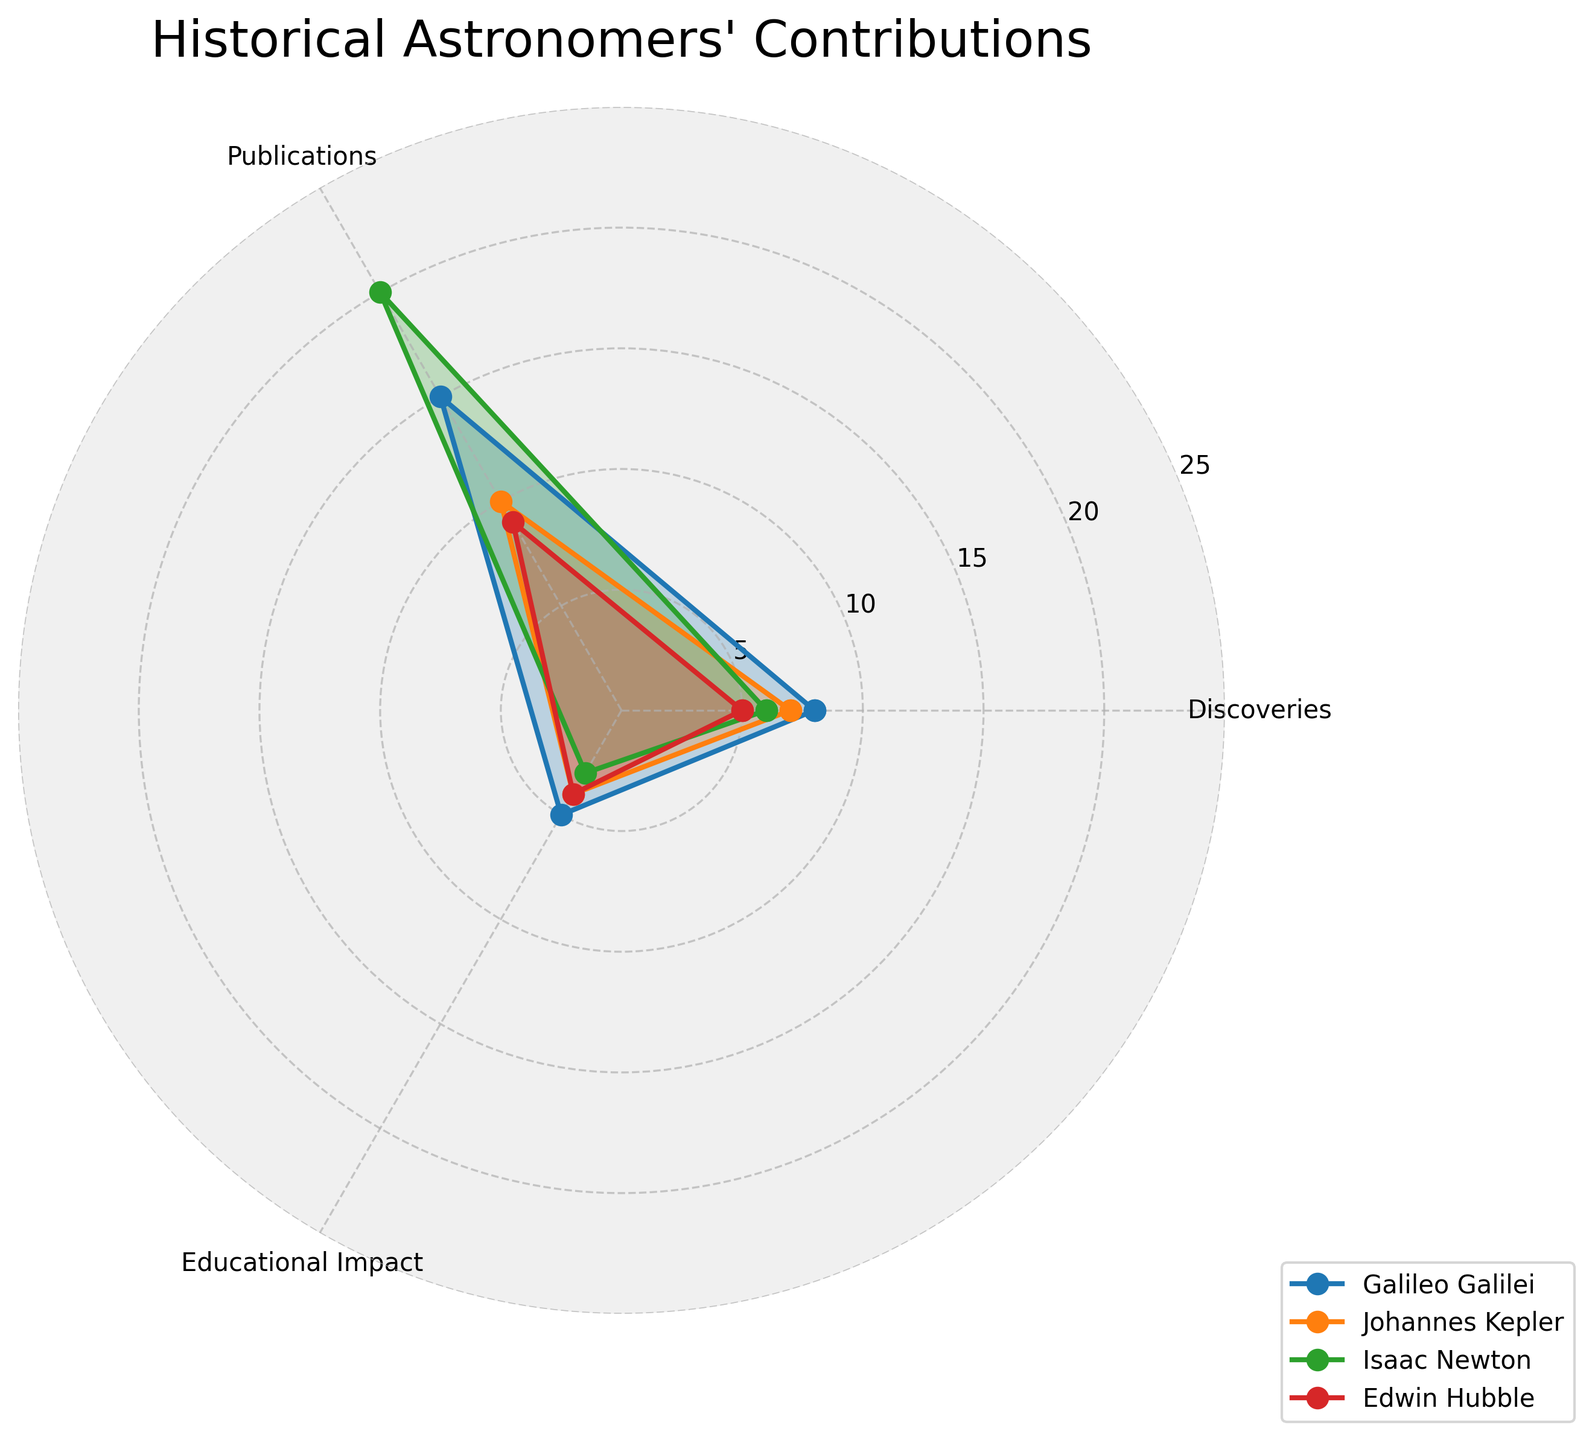What is the title of the radar chart? The title is generally displayed prominently at the top of the chart.
Answer: Historical Astronomers' Contributions What are the three categories displayed in the radar chart? The categories are listed around the radar chart as labels for axes.
Answer: Discoveries, Publications, Educational Impact Who has the highest number of discoveries according to the radar chart? By checking each astronomer's scores in the Discoveries category, we see who has the highest value. Galileo Galilei's point extends furthest in this section.
Answer: Galileo Galilei Which astronomer has the least educational impact? Compare the values for the Educational Impact category among all astronomers. Isaac Newton has the lowest value in this section.
Answer: Isaac Newton How many publications does Isaac Newton have? Locate the Publications axis and see where Isaac Newton's line intersects it. Isaac Newton's line reaches up to the highest value in this category.
Answer: 20 Whose contributions in publications are closest to Edwin Hubble's? Check the Publications values for each astronomer and see whose value is nearest to Edwin Hubble's score of 9. Johannes Kepler's value is 10, which is closest.
Answer: Johannes Kepler What is the average educational impact value among all astronomers? Sum up the educational impact values: 5 + 4 + 3 + 4 = 16. Then, divide by the number of astronomers: 16 / 4 = 4.
Answer: 4 Among all categories, where did Johannes Kepler score the highest? By examining each category for Johannes Kepler, his highest score is found in the Discoveries category.
Answer: Discoveries Compare the sum of Discoveries and Educational Impact for Edwin Hubble. How does it compare to Isaac Newton’s publications alone? Sum Edwin Hubble's Discoveries and Educational Impact: 5 + 4 = 9. Compare this with Isaac Newton’s Publications of 20. 9 is less than 20.
Answer: Lesser Which astronomer's contributions appear most balanced across all categories? Look for the astronomer whose lines are closest to forming an equilateral shape within the chart. Johannes Kepler's contributions appear quite balanced as his scores across categories don't deviate much.
Answer: Johannes Kepler 